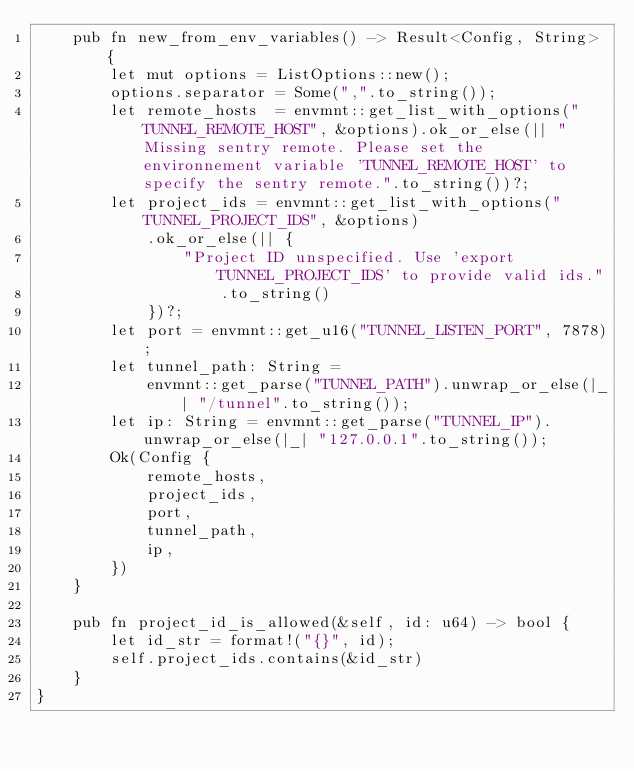<code> <loc_0><loc_0><loc_500><loc_500><_Rust_>    pub fn new_from_env_variables() -> Result<Config, String> {
        let mut options = ListOptions::new();
        options.separator = Some(",".to_string());
        let remote_hosts  = envmnt::get_list_with_options("TUNNEL_REMOTE_HOST", &options).ok_or_else(|| "Missing sentry remote. Please set the environnement variable 'TUNNEL_REMOTE_HOST' to specify the sentry remote.".to_string())?;
        let project_ids = envmnt::get_list_with_options("TUNNEL_PROJECT_IDS", &options)
            .ok_or_else(|| {
                "Project ID unspecified. Use 'export TUNNEL_PROJECT_IDS' to provide valid ids."
                    .to_string()
            })?;
        let port = envmnt::get_u16("TUNNEL_LISTEN_PORT", 7878);
        let tunnel_path: String =
            envmnt::get_parse("TUNNEL_PATH").unwrap_or_else(|_| "/tunnel".to_string());
        let ip: String = envmnt::get_parse("TUNNEL_IP").unwrap_or_else(|_| "127.0.0.1".to_string());
        Ok(Config {
            remote_hosts,
            project_ids,
            port,
            tunnel_path,
            ip,
        })
    }

    pub fn project_id_is_allowed(&self, id: u64) -> bool {
        let id_str = format!("{}", id);
        self.project_ids.contains(&id_str)
    }
}
</code> 